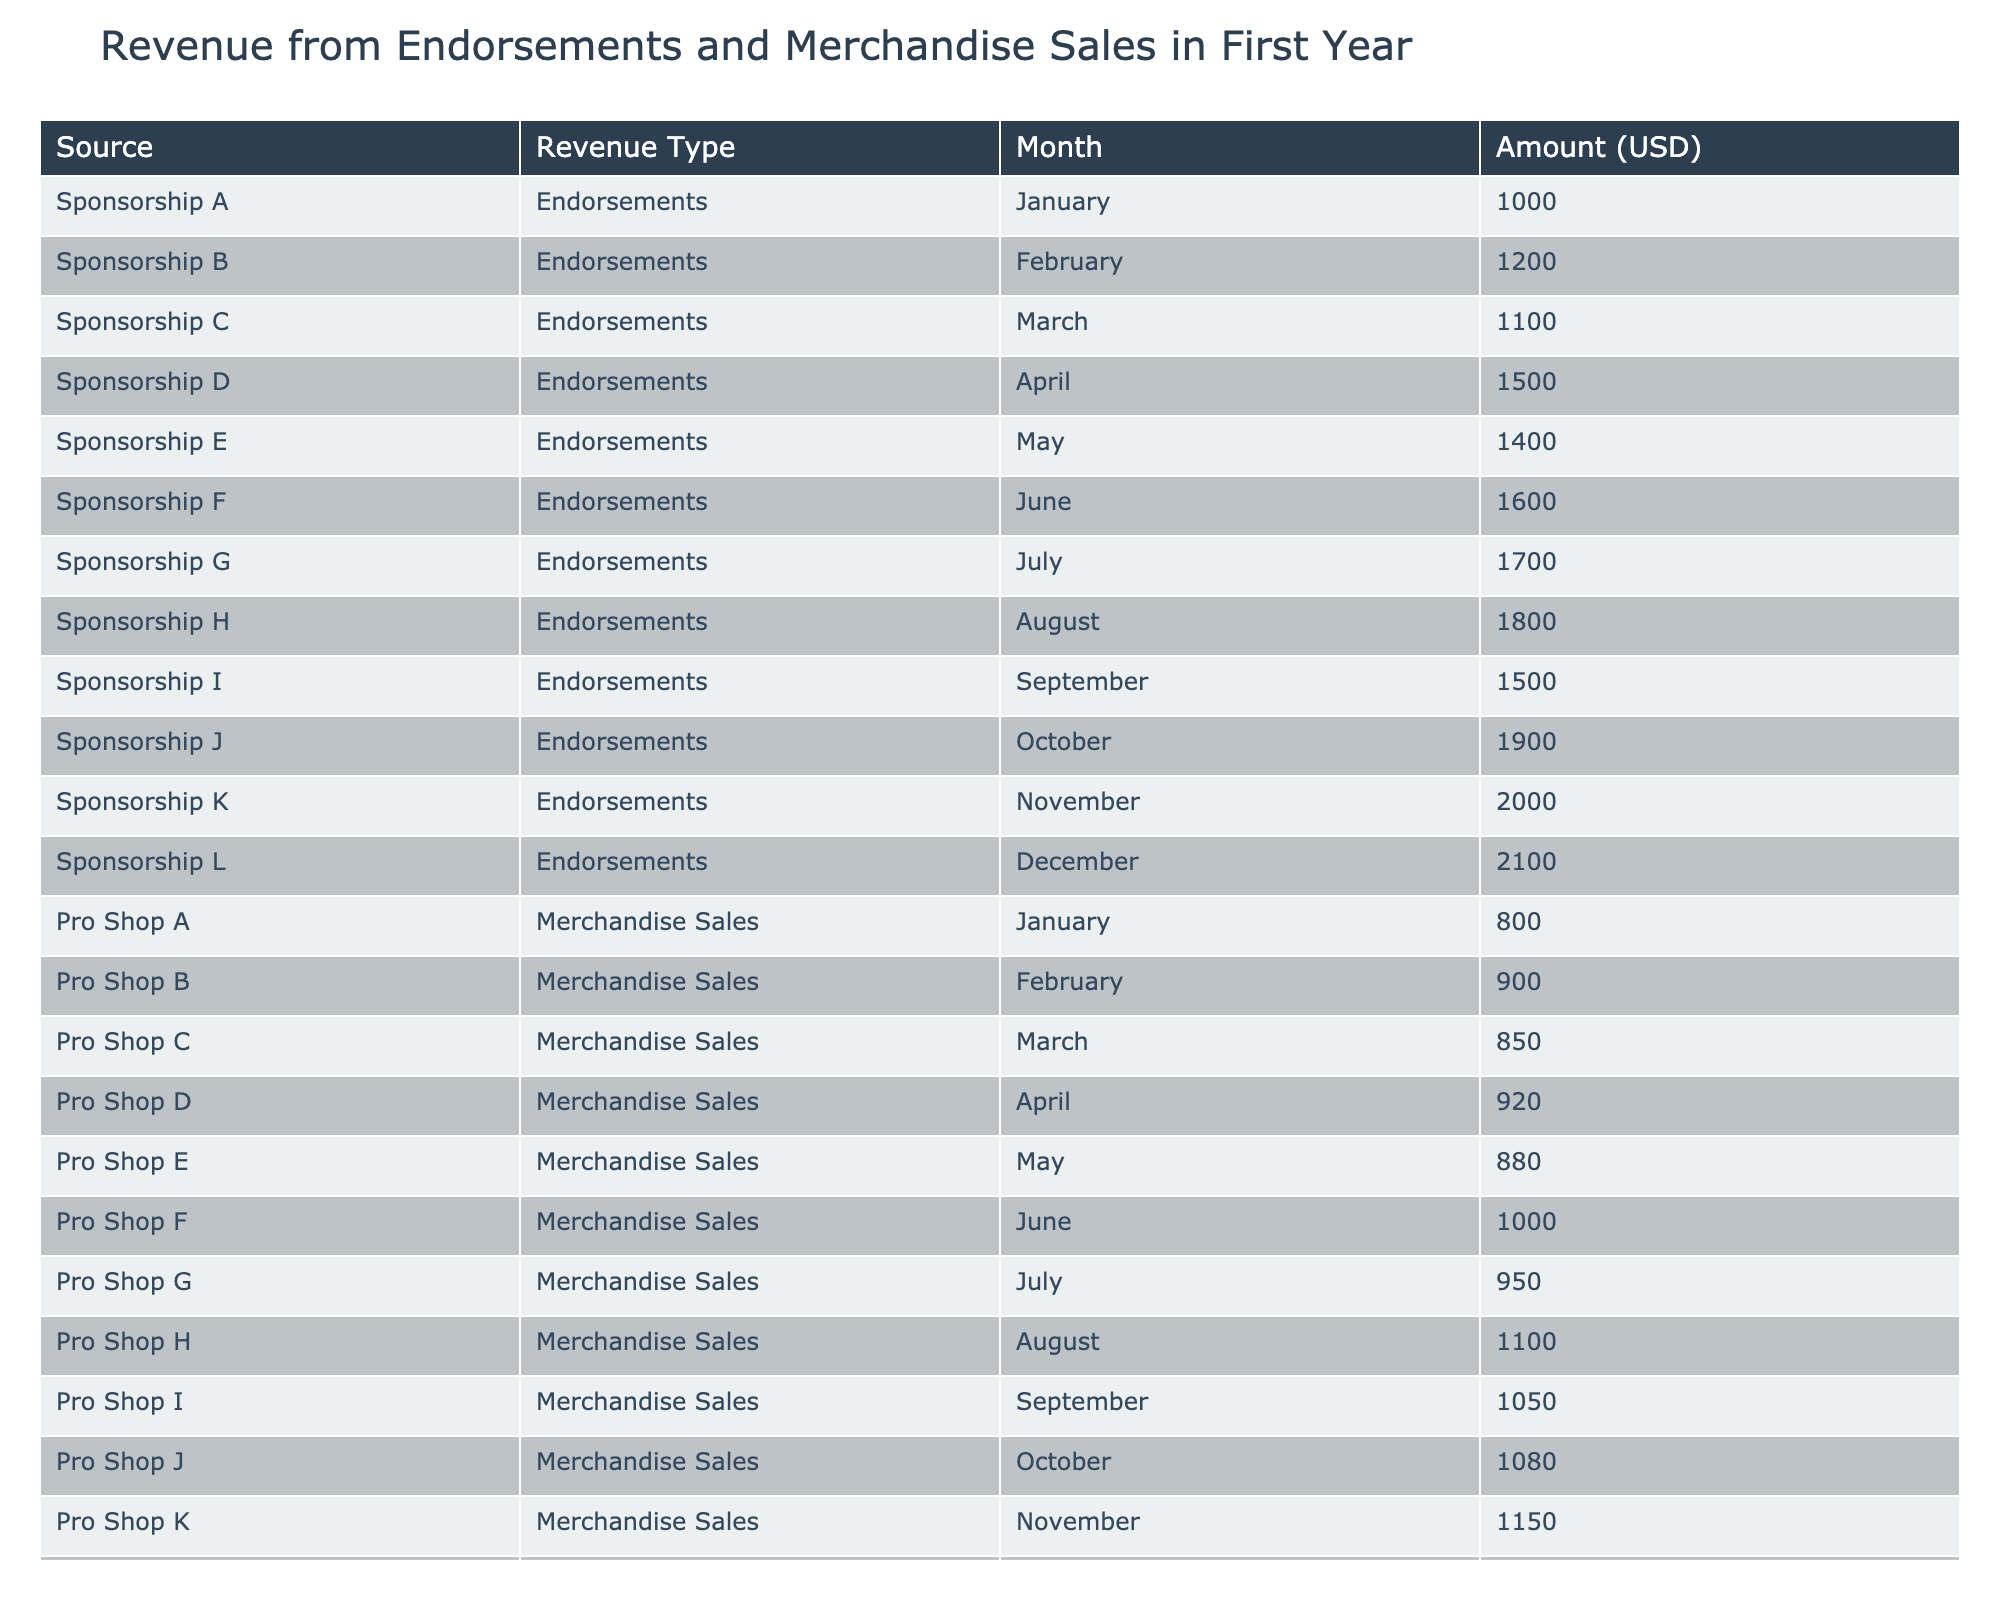What is the total revenue from endorsements in the month of December? The table shows that in December, the amount from endorsements under "Sponsorship L" is 2100 USD.
Answer: 2100 USD What are the revenue amounts from merchandise sales in April? In April, the merchandise sales amount under "Pro Shop D" is 920 USD.
Answer: 920 USD What is the average endorsement revenue over the year? To calculate the average, we first sum all the monthly endorsement revenues: 1000 + 1200 + 1100 + 1500 + 1400 + 1600 + 1700 + 1800 + 1500 + 1900 + 2000 + 2100 = 18700. We then divide by 12 (the number of months), which equals 1558.33.
Answer: 1558.33 USD Did the merchandise sales revenue exceed the endorsement revenue for any month? Comparing each month's merchandise sales to endorsements, in August both had 1800 USD, while in other months, endorsements were higher. Therefore, the answer is no.
Answer: No What is the difference between the highest endorsement and merchandise sales revenue in November? The highest endorsement revenue in November is 2000 USD (Sponsorship K), and the highest merchandise sales revenue is 1150 USD (Pro Shop K). The difference is 2000 - 1150 = 850 USD.
Answer: 850 USD What was the highest revenue month for endorsements? The highest endorsement revenue was in December (Sponsorship L) with 2100 USD.
Answer: December What are the total revenues from merchandise sales for the first half of the year? The first half of the year includes January to June. Calculating the sum: 800 + 900 + 850 + 920 + 880 + 1000 = 4350 USD indicates the total revenue from merchandise sales in that period.
Answer: 4350 USD Is the total revenue from all endorsements greater than the total revenue from all merchandise sales? The total revenue from endorsements is 18700 USD, and from merchandise sales, it is 12750 USD. Since 18700 is greater than 12750, the answer is yes.
Answer: Yes Which month had the highest merchandise sales revenue? The month with the highest merchandise sales revenue is December, under "Pro Shop L," with an amount of 1200 USD.
Answer: December 